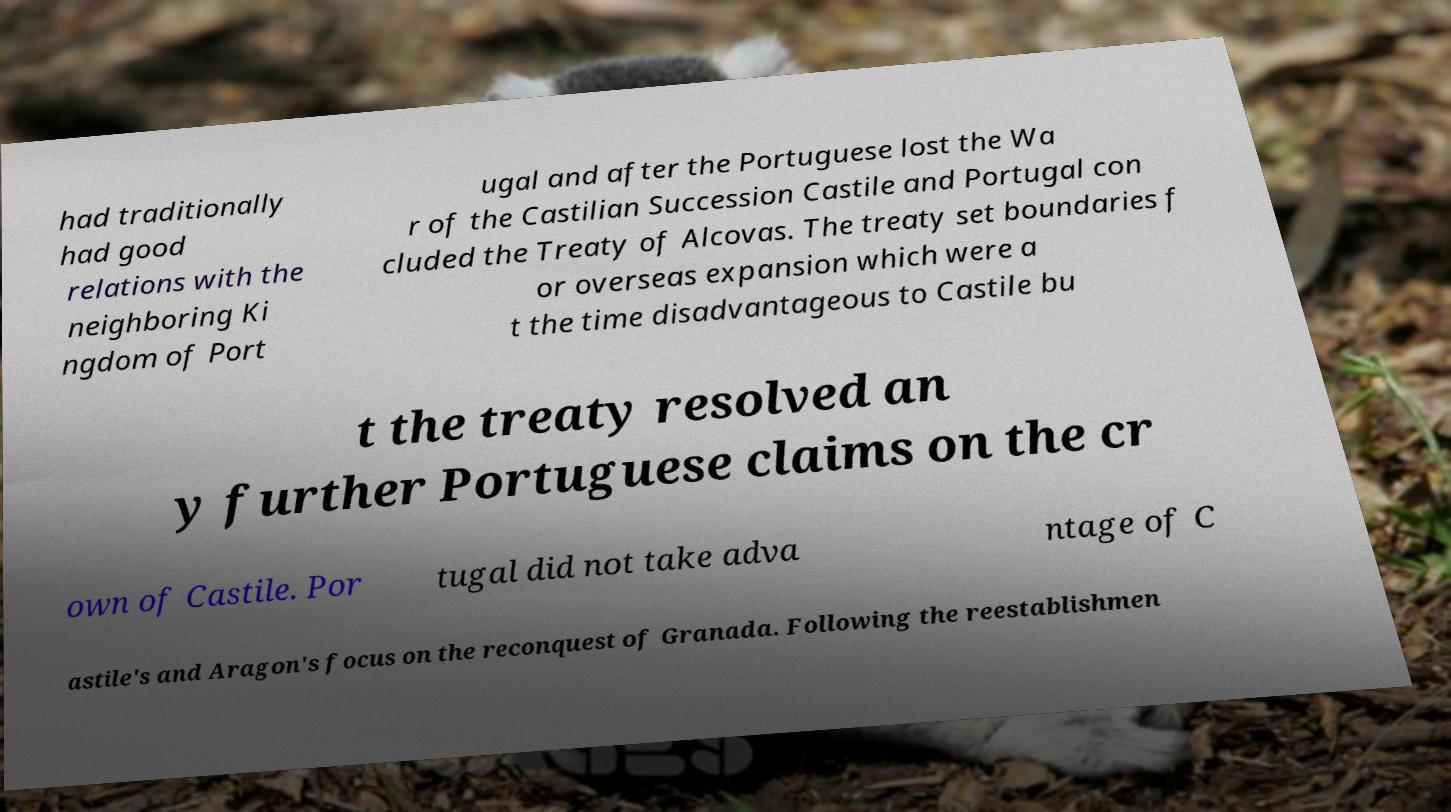For documentation purposes, I need the text within this image transcribed. Could you provide that? had traditionally had good relations with the neighboring Ki ngdom of Port ugal and after the Portuguese lost the Wa r of the Castilian Succession Castile and Portugal con cluded the Treaty of Alcovas. The treaty set boundaries f or overseas expansion which were a t the time disadvantageous to Castile bu t the treaty resolved an y further Portuguese claims on the cr own of Castile. Por tugal did not take adva ntage of C astile's and Aragon's focus on the reconquest of Granada. Following the reestablishmen 